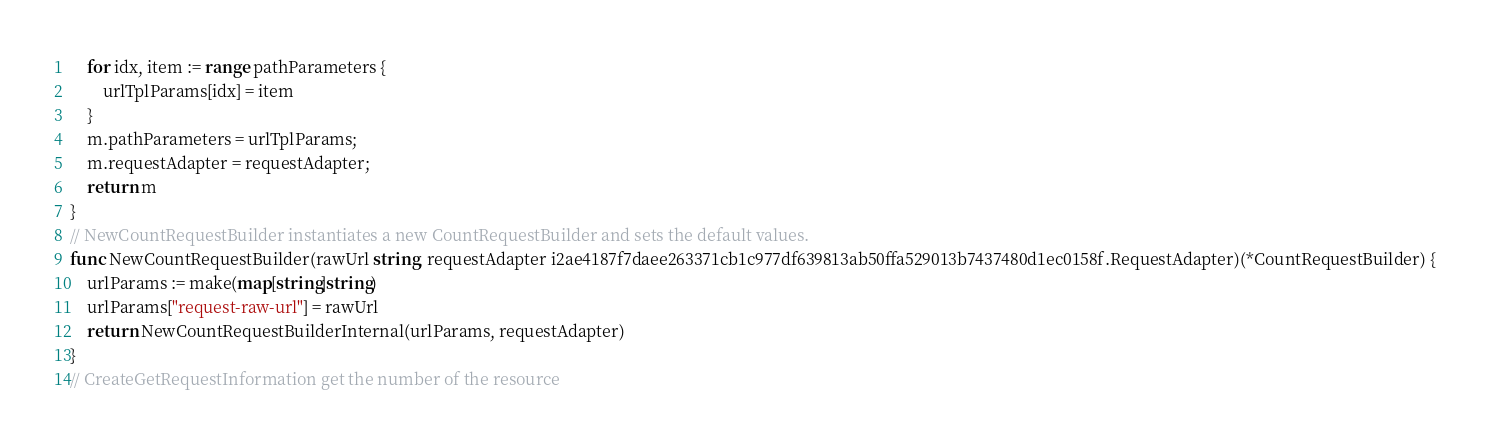<code> <loc_0><loc_0><loc_500><loc_500><_Go_>    for idx, item := range pathParameters {
        urlTplParams[idx] = item
    }
    m.pathParameters = urlTplParams;
    m.requestAdapter = requestAdapter;
    return m
}
// NewCountRequestBuilder instantiates a new CountRequestBuilder and sets the default values.
func NewCountRequestBuilder(rawUrl string, requestAdapter i2ae4187f7daee263371cb1c977df639813ab50ffa529013b7437480d1ec0158f.RequestAdapter)(*CountRequestBuilder) {
    urlParams := make(map[string]string)
    urlParams["request-raw-url"] = rawUrl
    return NewCountRequestBuilderInternal(urlParams, requestAdapter)
}
// CreateGetRequestInformation get the number of the resource</code> 